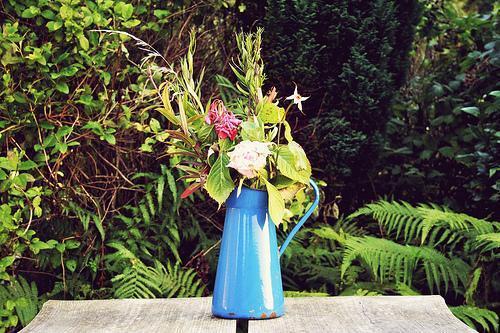How many vases are there?
Give a very brief answer. 1. 